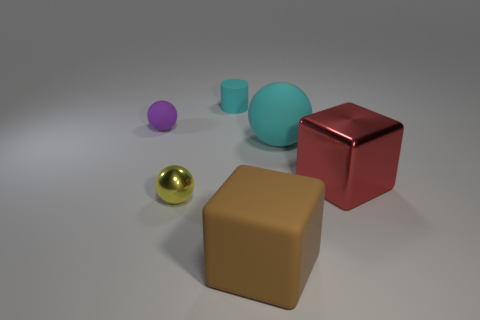Subtract all tiny balls. How many balls are left? 1 Subtract 1 cubes. How many cubes are left? 1 Subtract all yellow spheres. How many spheres are left? 2 Subtract all cylinders. How many objects are left? 5 Subtract all green cylinders. How many purple balls are left? 1 Subtract all big brown matte balls. Subtract all small yellow objects. How many objects are left? 5 Add 2 cyan rubber spheres. How many cyan rubber spheres are left? 3 Add 3 yellow rubber things. How many yellow rubber things exist? 3 Add 4 small purple rubber spheres. How many objects exist? 10 Subtract 1 red cubes. How many objects are left? 5 